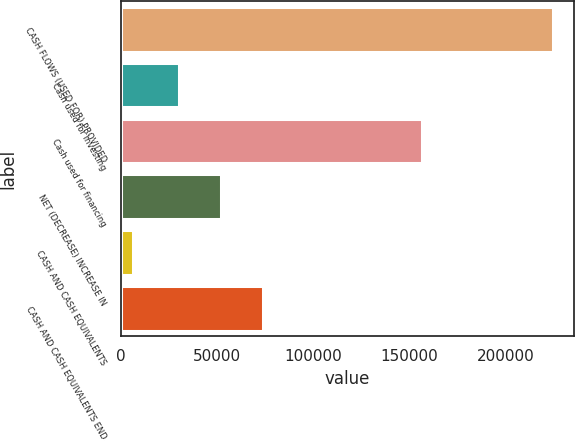Convert chart to OTSL. <chart><loc_0><loc_0><loc_500><loc_500><bar_chart><fcel>CASH FLOWS (USED FOR) PROVIDED<fcel>Cash used for investing<fcel>Cash used for financing<fcel>NET (DECREASE) INCREASE IN<fcel>CASH AND CASH EQUIVALENTS<fcel>CASH AND CASH EQUIVALENTS END<nl><fcel>224524<fcel>30278<fcel>156447<fcel>52113<fcel>6174<fcel>73948<nl></chart> 